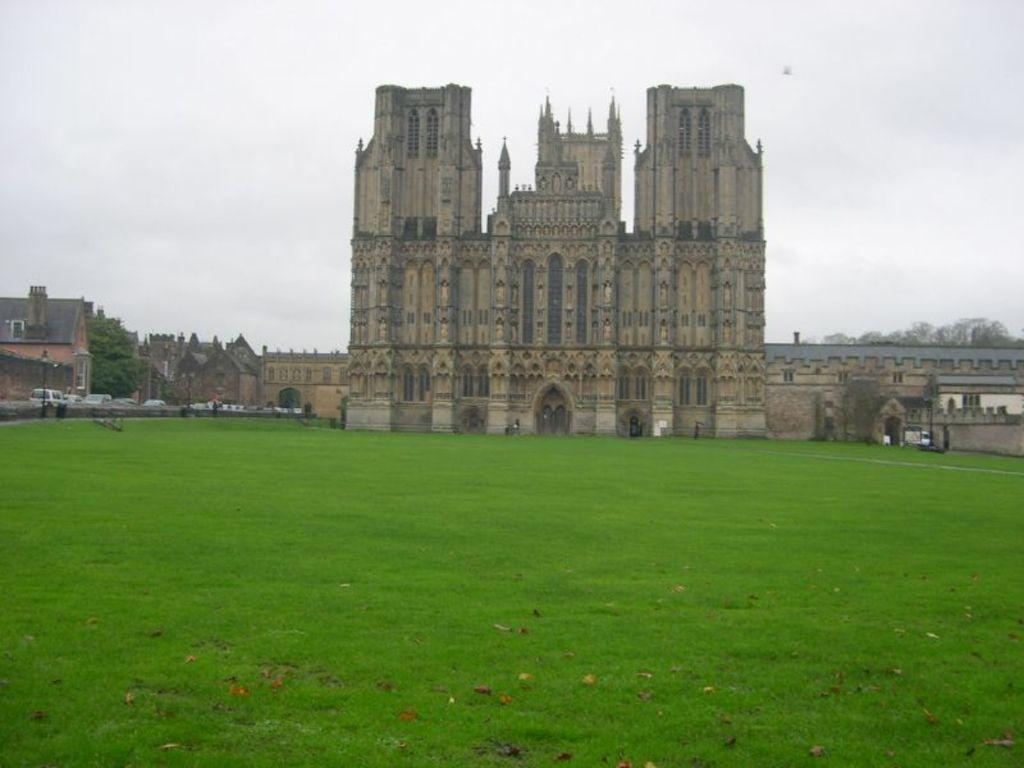Can you describe this image briefly? In this picture we can see leaves on the grass, buildings, trees, vehicles, poles and some objects and in the background we can see the sky. 